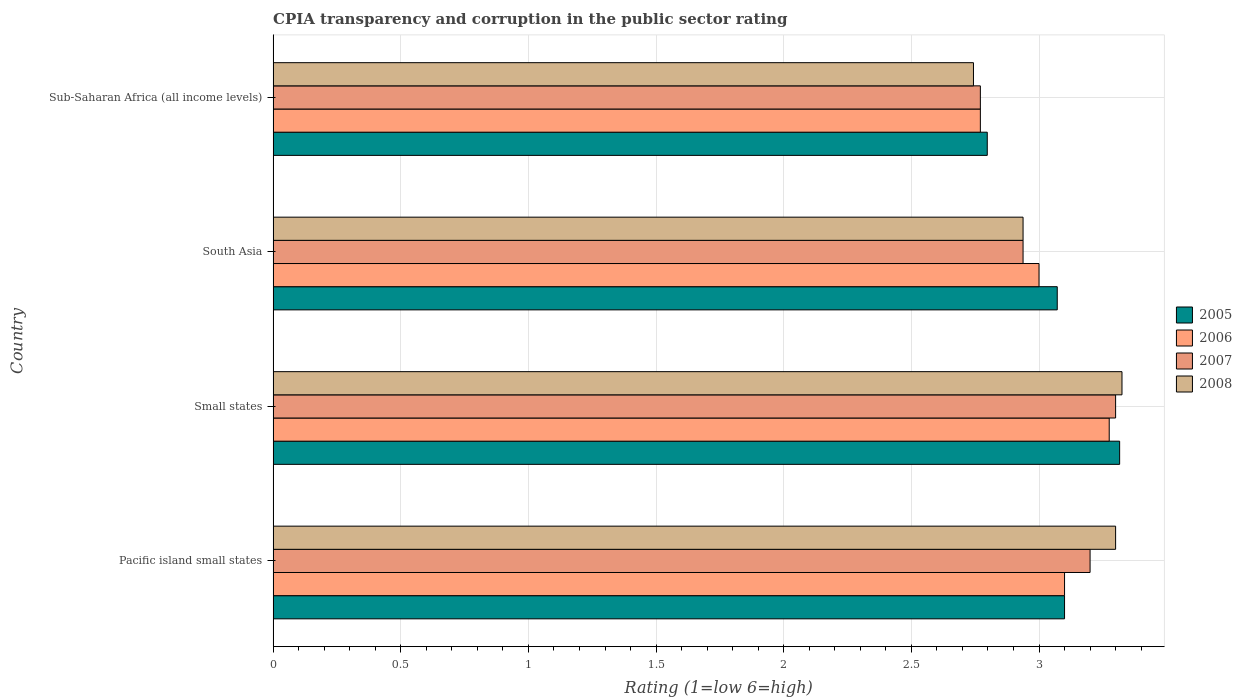How many different coloured bars are there?
Provide a short and direct response. 4. What is the label of the 3rd group of bars from the top?
Your response must be concise. Small states. Across all countries, what is the maximum CPIA rating in 2005?
Ensure brevity in your answer.  3.32. Across all countries, what is the minimum CPIA rating in 2008?
Your answer should be very brief. 2.74. In which country was the CPIA rating in 2005 maximum?
Provide a short and direct response. Small states. In which country was the CPIA rating in 2008 minimum?
Ensure brevity in your answer.  Sub-Saharan Africa (all income levels). What is the total CPIA rating in 2007 in the graph?
Offer a terse response. 12.21. What is the difference between the CPIA rating in 2006 in South Asia and that in Sub-Saharan Africa (all income levels)?
Provide a succinct answer. 0.23. What is the difference between the CPIA rating in 2007 in South Asia and the CPIA rating in 2005 in Small states?
Offer a terse response. -0.38. What is the average CPIA rating in 2005 per country?
Your answer should be compact. 3.07. What is the difference between the CPIA rating in 2006 and CPIA rating in 2005 in Small states?
Give a very brief answer. -0.04. What is the ratio of the CPIA rating in 2006 in South Asia to that in Sub-Saharan Africa (all income levels)?
Offer a terse response. 1.08. Is the CPIA rating in 2008 in Pacific island small states less than that in Sub-Saharan Africa (all income levels)?
Give a very brief answer. No. What is the difference between the highest and the second highest CPIA rating in 2007?
Your response must be concise. 0.1. What is the difference between the highest and the lowest CPIA rating in 2008?
Provide a short and direct response. 0.58. What does the 2nd bar from the top in South Asia represents?
Your response must be concise. 2007. Is it the case that in every country, the sum of the CPIA rating in 2005 and CPIA rating in 2007 is greater than the CPIA rating in 2008?
Provide a short and direct response. Yes. How many bars are there?
Ensure brevity in your answer.  16. How many countries are there in the graph?
Ensure brevity in your answer.  4. What is the difference between two consecutive major ticks on the X-axis?
Make the answer very short. 0.5. Does the graph contain any zero values?
Your answer should be very brief. No. Does the graph contain grids?
Provide a short and direct response. Yes. Where does the legend appear in the graph?
Your response must be concise. Center right. How many legend labels are there?
Keep it short and to the point. 4. How are the legend labels stacked?
Your response must be concise. Vertical. What is the title of the graph?
Offer a terse response. CPIA transparency and corruption in the public sector rating. Does "1976" appear as one of the legend labels in the graph?
Offer a very short reply. No. What is the label or title of the X-axis?
Give a very brief answer. Rating (1=low 6=high). What is the label or title of the Y-axis?
Your answer should be very brief. Country. What is the Rating (1=low 6=high) of 2005 in Small states?
Provide a succinct answer. 3.32. What is the Rating (1=low 6=high) in 2006 in Small states?
Make the answer very short. 3.27. What is the Rating (1=low 6=high) of 2007 in Small states?
Provide a succinct answer. 3.3. What is the Rating (1=low 6=high) in 2008 in Small states?
Ensure brevity in your answer.  3.33. What is the Rating (1=low 6=high) of 2005 in South Asia?
Your answer should be compact. 3.07. What is the Rating (1=low 6=high) in 2007 in South Asia?
Offer a very short reply. 2.94. What is the Rating (1=low 6=high) of 2008 in South Asia?
Provide a succinct answer. 2.94. What is the Rating (1=low 6=high) in 2005 in Sub-Saharan Africa (all income levels)?
Keep it short and to the point. 2.8. What is the Rating (1=low 6=high) in 2006 in Sub-Saharan Africa (all income levels)?
Your answer should be very brief. 2.77. What is the Rating (1=low 6=high) in 2007 in Sub-Saharan Africa (all income levels)?
Provide a short and direct response. 2.77. What is the Rating (1=low 6=high) of 2008 in Sub-Saharan Africa (all income levels)?
Make the answer very short. 2.74. Across all countries, what is the maximum Rating (1=low 6=high) of 2005?
Provide a short and direct response. 3.32. Across all countries, what is the maximum Rating (1=low 6=high) in 2006?
Give a very brief answer. 3.27. Across all countries, what is the maximum Rating (1=low 6=high) in 2007?
Give a very brief answer. 3.3. Across all countries, what is the maximum Rating (1=low 6=high) in 2008?
Provide a succinct answer. 3.33. Across all countries, what is the minimum Rating (1=low 6=high) in 2005?
Give a very brief answer. 2.8. Across all countries, what is the minimum Rating (1=low 6=high) of 2006?
Keep it short and to the point. 2.77. Across all countries, what is the minimum Rating (1=low 6=high) in 2007?
Make the answer very short. 2.77. Across all countries, what is the minimum Rating (1=low 6=high) in 2008?
Give a very brief answer. 2.74. What is the total Rating (1=low 6=high) in 2005 in the graph?
Give a very brief answer. 12.28. What is the total Rating (1=low 6=high) in 2006 in the graph?
Your answer should be compact. 12.15. What is the total Rating (1=low 6=high) of 2007 in the graph?
Your answer should be very brief. 12.21. What is the total Rating (1=low 6=high) of 2008 in the graph?
Offer a terse response. 12.31. What is the difference between the Rating (1=low 6=high) of 2005 in Pacific island small states and that in Small states?
Provide a short and direct response. -0.22. What is the difference between the Rating (1=low 6=high) in 2006 in Pacific island small states and that in Small states?
Provide a succinct answer. -0.17. What is the difference between the Rating (1=low 6=high) in 2008 in Pacific island small states and that in Small states?
Ensure brevity in your answer.  -0.03. What is the difference between the Rating (1=low 6=high) of 2005 in Pacific island small states and that in South Asia?
Your answer should be compact. 0.03. What is the difference between the Rating (1=low 6=high) in 2007 in Pacific island small states and that in South Asia?
Ensure brevity in your answer.  0.26. What is the difference between the Rating (1=low 6=high) in 2008 in Pacific island small states and that in South Asia?
Offer a terse response. 0.36. What is the difference between the Rating (1=low 6=high) of 2005 in Pacific island small states and that in Sub-Saharan Africa (all income levels)?
Provide a short and direct response. 0.3. What is the difference between the Rating (1=low 6=high) of 2006 in Pacific island small states and that in Sub-Saharan Africa (all income levels)?
Provide a short and direct response. 0.33. What is the difference between the Rating (1=low 6=high) in 2007 in Pacific island small states and that in Sub-Saharan Africa (all income levels)?
Offer a terse response. 0.43. What is the difference between the Rating (1=low 6=high) in 2008 in Pacific island small states and that in Sub-Saharan Africa (all income levels)?
Make the answer very short. 0.56. What is the difference between the Rating (1=low 6=high) in 2005 in Small states and that in South Asia?
Provide a succinct answer. 0.24. What is the difference between the Rating (1=low 6=high) of 2006 in Small states and that in South Asia?
Give a very brief answer. 0.28. What is the difference between the Rating (1=low 6=high) of 2007 in Small states and that in South Asia?
Ensure brevity in your answer.  0.36. What is the difference between the Rating (1=low 6=high) of 2008 in Small states and that in South Asia?
Ensure brevity in your answer.  0.39. What is the difference between the Rating (1=low 6=high) in 2005 in Small states and that in Sub-Saharan Africa (all income levels)?
Offer a very short reply. 0.52. What is the difference between the Rating (1=low 6=high) of 2006 in Small states and that in Sub-Saharan Africa (all income levels)?
Your answer should be compact. 0.5. What is the difference between the Rating (1=low 6=high) of 2007 in Small states and that in Sub-Saharan Africa (all income levels)?
Your answer should be very brief. 0.53. What is the difference between the Rating (1=low 6=high) in 2008 in Small states and that in Sub-Saharan Africa (all income levels)?
Your answer should be very brief. 0.58. What is the difference between the Rating (1=low 6=high) of 2005 in South Asia and that in Sub-Saharan Africa (all income levels)?
Keep it short and to the point. 0.27. What is the difference between the Rating (1=low 6=high) of 2006 in South Asia and that in Sub-Saharan Africa (all income levels)?
Keep it short and to the point. 0.23. What is the difference between the Rating (1=low 6=high) in 2007 in South Asia and that in Sub-Saharan Africa (all income levels)?
Provide a succinct answer. 0.17. What is the difference between the Rating (1=low 6=high) in 2008 in South Asia and that in Sub-Saharan Africa (all income levels)?
Provide a short and direct response. 0.19. What is the difference between the Rating (1=low 6=high) in 2005 in Pacific island small states and the Rating (1=low 6=high) in 2006 in Small states?
Your answer should be compact. -0.17. What is the difference between the Rating (1=low 6=high) in 2005 in Pacific island small states and the Rating (1=low 6=high) in 2008 in Small states?
Provide a succinct answer. -0.23. What is the difference between the Rating (1=low 6=high) in 2006 in Pacific island small states and the Rating (1=low 6=high) in 2007 in Small states?
Offer a very short reply. -0.2. What is the difference between the Rating (1=low 6=high) of 2006 in Pacific island small states and the Rating (1=low 6=high) of 2008 in Small states?
Offer a very short reply. -0.23. What is the difference between the Rating (1=low 6=high) of 2007 in Pacific island small states and the Rating (1=low 6=high) of 2008 in Small states?
Keep it short and to the point. -0.12. What is the difference between the Rating (1=low 6=high) in 2005 in Pacific island small states and the Rating (1=low 6=high) in 2006 in South Asia?
Your answer should be compact. 0.1. What is the difference between the Rating (1=low 6=high) in 2005 in Pacific island small states and the Rating (1=low 6=high) in 2007 in South Asia?
Keep it short and to the point. 0.16. What is the difference between the Rating (1=low 6=high) of 2005 in Pacific island small states and the Rating (1=low 6=high) of 2008 in South Asia?
Keep it short and to the point. 0.16. What is the difference between the Rating (1=low 6=high) in 2006 in Pacific island small states and the Rating (1=low 6=high) in 2007 in South Asia?
Provide a succinct answer. 0.16. What is the difference between the Rating (1=low 6=high) of 2006 in Pacific island small states and the Rating (1=low 6=high) of 2008 in South Asia?
Keep it short and to the point. 0.16. What is the difference between the Rating (1=low 6=high) in 2007 in Pacific island small states and the Rating (1=low 6=high) in 2008 in South Asia?
Your response must be concise. 0.26. What is the difference between the Rating (1=low 6=high) of 2005 in Pacific island small states and the Rating (1=low 6=high) of 2006 in Sub-Saharan Africa (all income levels)?
Offer a very short reply. 0.33. What is the difference between the Rating (1=low 6=high) of 2005 in Pacific island small states and the Rating (1=low 6=high) of 2007 in Sub-Saharan Africa (all income levels)?
Provide a succinct answer. 0.33. What is the difference between the Rating (1=low 6=high) of 2005 in Pacific island small states and the Rating (1=low 6=high) of 2008 in Sub-Saharan Africa (all income levels)?
Your response must be concise. 0.36. What is the difference between the Rating (1=low 6=high) of 2006 in Pacific island small states and the Rating (1=low 6=high) of 2007 in Sub-Saharan Africa (all income levels)?
Provide a succinct answer. 0.33. What is the difference between the Rating (1=low 6=high) of 2006 in Pacific island small states and the Rating (1=low 6=high) of 2008 in Sub-Saharan Africa (all income levels)?
Your answer should be very brief. 0.36. What is the difference between the Rating (1=low 6=high) in 2007 in Pacific island small states and the Rating (1=low 6=high) in 2008 in Sub-Saharan Africa (all income levels)?
Your response must be concise. 0.46. What is the difference between the Rating (1=low 6=high) in 2005 in Small states and the Rating (1=low 6=high) in 2006 in South Asia?
Your answer should be very brief. 0.32. What is the difference between the Rating (1=low 6=high) of 2005 in Small states and the Rating (1=low 6=high) of 2007 in South Asia?
Offer a very short reply. 0.38. What is the difference between the Rating (1=low 6=high) in 2005 in Small states and the Rating (1=low 6=high) in 2008 in South Asia?
Make the answer very short. 0.38. What is the difference between the Rating (1=low 6=high) in 2006 in Small states and the Rating (1=low 6=high) in 2007 in South Asia?
Give a very brief answer. 0.34. What is the difference between the Rating (1=low 6=high) of 2006 in Small states and the Rating (1=low 6=high) of 2008 in South Asia?
Offer a terse response. 0.34. What is the difference between the Rating (1=low 6=high) of 2007 in Small states and the Rating (1=low 6=high) of 2008 in South Asia?
Provide a succinct answer. 0.36. What is the difference between the Rating (1=low 6=high) of 2005 in Small states and the Rating (1=low 6=high) of 2006 in Sub-Saharan Africa (all income levels)?
Provide a succinct answer. 0.55. What is the difference between the Rating (1=low 6=high) in 2005 in Small states and the Rating (1=low 6=high) in 2007 in Sub-Saharan Africa (all income levels)?
Offer a terse response. 0.55. What is the difference between the Rating (1=low 6=high) in 2005 in Small states and the Rating (1=low 6=high) in 2008 in Sub-Saharan Africa (all income levels)?
Make the answer very short. 0.57. What is the difference between the Rating (1=low 6=high) in 2006 in Small states and the Rating (1=low 6=high) in 2007 in Sub-Saharan Africa (all income levels)?
Your answer should be compact. 0.5. What is the difference between the Rating (1=low 6=high) of 2006 in Small states and the Rating (1=low 6=high) of 2008 in Sub-Saharan Africa (all income levels)?
Your answer should be compact. 0.53. What is the difference between the Rating (1=low 6=high) in 2007 in Small states and the Rating (1=low 6=high) in 2008 in Sub-Saharan Africa (all income levels)?
Keep it short and to the point. 0.56. What is the difference between the Rating (1=low 6=high) in 2005 in South Asia and the Rating (1=low 6=high) in 2006 in Sub-Saharan Africa (all income levels)?
Offer a terse response. 0.3. What is the difference between the Rating (1=low 6=high) in 2005 in South Asia and the Rating (1=low 6=high) in 2007 in Sub-Saharan Africa (all income levels)?
Offer a very short reply. 0.3. What is the difference between the Rating (1=low 6=high) in 2005 in South Asia and the Rating (1=low 6=high) in 2008 in Sub-Saharan Africa (all income levels)?
Your response must be concise. 0.33. What is the difference between the Rating (1=low 6=high) of 2006 in South Asia and the Rating (1=low 6=high) of 2007 in Sub-Saharan Africa (all income levels)?
Your answer should be very brief. 0.23. What is the difference between the Rating (1=low 6=high) in 2006 in South Asia and the Rating (1=low 6=high) in 2008 in Sub-Saharan Africa (all income levels)?
Your answer should be very brief. 0.26. What is the difference between the Rating (1=low 6=high) of 2007 in South Asia and the Rating (1=low 6=high) of 2008 in Sub-Saharan Africa (all income levels)?
Provide a succinct answer. 0.19. What is the average Rating (1=low 6=high) of 2005 per country?
Your answer should be very brief. 3.07. What is the average Rating (1=low 6=high) of 2006 per country?
Keep it short and to the point. 3.04. What is the average Rating (1=low 6=high) of 2007 per country?
Make the answer very short. 3.05. What is the average Rating (1=low 6=high) in 2008 per country?
Offer a very short reply. 3.08. What is the difference between the Rating (1=low 6=high) of 2005 and Rating (1=low 6=high) of 2008 in Pacific island small states?
Your answer should be compact. -0.2. What is the difference between the Rating (1=low 6=high) in 2006 and Rating (1=low 6=high) in 2007 in Pacific island small states?
Your answer should be very brief. -0.1. What is the difference between the Rating (1=low 6=high) of 2006 and Rating (1=low 6=high) of 2008 in Pacific island small states?
Your answer should be very brief. -0.2. What is the difference between the Rating (1=low 6=high) of 2007 and Rating (1=low 6=high) of 2008 in Pacific island small states?
Offer a terse response. -0.1. What is the difference between the Rating (1=low 6=high) of 2005 and Rating (1=low 6=high) of 2006 in Small states?
Offer a terse response. 0.04. What is the difference between the Rating (1=low 6=high) in 2005 and Rating (1=low 6=high) in 2007 in Small states?
Offer a terse response. 0.02. What is the difference between the Rating (1=low 6=high) of 2005 and Rating (1=low 6=high) of 2008 in Small states?
Ensure brevity in your answer.  -0.01. What is the difference between the Rating (1=low 6=high) in 2006 and Rating (1=low 6=high) in 2007 in Small states?
Your answer should be very brief. -0.03. What is the difference between the Rating (1=low 6=high) of 2006 and Rating (1=low 6=high) of 2008 in Small states?
Offer a terse response. -0.05. What is the difference between the Rating (1=low 6=high) of 2007 and Rating (1=low 6=high) of 2008 in Small states?
Your response must be concise. -0.03. What is the difference between the Rating (1=low 6=high) in 2005 and Rating (1=low 6=high) in 2006 in South Asia?
Offer a very short reply. 0.07. What is the difference between the Rating (1=low 6=high) in 2005 and Rating (1=low 6=high) in 2007 in South Asia?
Make the answer very short. 0.13. What is the difference between the Rating (1=low 6=high) of 2005 and Rating (1=low 6=high) of 2008 in South Asia?
Your answer should be compact. 0.13. What is the difference between the Rating (1=low 6=high) of 2006 and Rating (1=low 6=high) of 2007 in South Asia?
Provide a succinct answer. 0.06. What is the difference between the Rating (1=low 6=high) of 2006 and Rating (1=low 6=high) of 2008 in South Asia?
Make the answer very short. 0.06. What is the difference between the Rating (1=low 6=high) of 2007 and Rating (1=low 6=high) of 2008 in South Asia?
Give a very brief answer. 0. What is the difference between the Rating (1=low 6=high) in 2005 and Rating (1=low 6=high) in 2006 in Sub-Saharan Africa (all income levels)?
Keep it short and to the point. 0.03. What is the difference between the Rating (1=low 6=high) in 2005 and Rating (1=low 6=high) in 2007 in Sub-Saharan Africa (all income levels)?
Give a very brief answer. 0.03. What is the difference between the Rating (1=low 6=high) in 2005 and Rating (1=low 6=high) in 2008 in Sub-Saharan Africa (all income levels)?
Make the answer very short. 0.05. What is the difference between the Rating (1=low 6=high) of 2006 and Rating (1=low 6=high) of 2008 in Sub-Saharan Africa (all income levels)?
Provide a short and direct response. 0.03. What is the difference between the Rating (1=low 6=high) of 2007 and Rating (1=low 6=high) of 2008 in Sub-Saharan Africa (all income levels)?
Offer a terse response. 0.03. What is the ratio of the Rating (1=low 6=high) of 2005 in Pacific island small states to that in Small states?
Provide a short and direct response. 0.93. What is the ratio of the Rating (1=low 6=high) in 2006 in Pacific island small states to that in Small states?
Offer a very short reply. 0.95. What is the ratio of the Rating (1=low 6=high) of 2007 in Pacific island small states to that in Small states?
Provide a succinct answer. 0.97. What is the ratio of the Rating (1=low 6=high) in 2008 in Pacific island small states to that in Small states?
Keep it short and to the point. 0.99. What is the ratio of the Rating (1=low 6=high) of 2005 in Pacific island small states to that in South Asia?
Your answer should be compact. 1.01. What is the ratio of the Rating (1=low 6=high) of 2006 in Pacific island small states to that in South Asia?
Offer a very short reply. 1.03. What is the ratio of the Rating (1=low 6=high) of 2007 in Pacific island small states to that in South Asia?
Give a very brief answer. 1.09. What is the ratio of the Rating (1=low 6=high) of 2008 in Pacific island small states to that in South Asia?
Keep it short and to the point. 1.12. What is the ratio of the Rating (1=low 6=high) in 2005 in Pacific island small states to that in Sub-Saharan Africa (all income levels)?
Keep it short and to the point. 1.11. What is the ratio of the Rating (1=low 6=high) of 2006 in Pacific island small states to that in Sub-Saharan Africa (all income levels)?
Your response must be concise. 1.12. What is the ratio of the Rating (1=low 6=high) in 2007 in Pacific island small states to that in Sub-Saharan Africa (all income levels)?
Your response must be concise. 1.16. What is the ratio of the Rating (1=low 6=high) of 2008 in Pacific island small states to that in Sub-Saharan Africa (all income levels)?
Give a very brief answer. 1.2. What is the ratio of the Rating (1=low 6=high) in 2005 in Small states to that in South Asia?
Make the answer very short. 1.08. What is the ratio of the Rating (1=low 6=high) of 2006 in Small states to that in South Asia?
Ensure brevity in your answer.  1.09. What is the ratio of the Rating (1=low 6=high) of 2007 in Small states to that in South Asia?
Provide a short and direct response. 1.12. What is the ratio of the Rating (1=low 6=high) in 2008 in Small states to that in South Asia?
Make the answer very short. 1.13. What is the ratio of the Rating (1=low 6=high) of 2005 in Small states to that in Sub-Saharan Africa (all income levels)?
Keep it short and to the point. 1.19. What is the ratio of the Rating (1=low 6=high) of 2006 in Small states to that in Sub-Saharan Africa (all income levels)?
Provide a short and direct response. 1.18. What is the ratio of the Rating (1=low 6=high) of 2007 in Small states to that in Sub-Saharan Africa (all income levels)?
Make the answer very short. 1.19. What is the ratio of the Rating (1=low 6=high) in 2008 in Small states to that in Sub-Saharan Africa (all income levels)?
Provide a succinct answer. 1.21. What is the ratio of the Rating (1=low 6=high) in 2005 in South Asia to that in Sub-Saharan Africa (all income levels)?
Make the answer very short. 1.1. What is the ratio of the Rating (1=low 6=high) of 2006 in South Asia to that in Sub-Saharan Africa (all income levels)?
Your response must be concise. 1.08. What is the ratio of the Rating (1=low 6=high) of 2007 in South Asia to that in Sub-Saharan Africa (all income levels)?
Provide a succinct answer. 1.06. What is the ratio of the Rating (1=low 6=high) in 2008 in South Asia to that in Sub-Saharan Africa (all income levels)?
Give a very brief answer. 1.07. What is the difference between the highest and the second highest Rating (1=low 6=high) of 2005?
Make the answer very short. 0.22. What is the difference between the highest and the second highest Rating (1=low 6=high) of 2006?
Offer a very short reply. 0.17. What is the difference between the highest and the second highest Rating (1=low 6=high) of 2008?
Keep it short and to the point. 0.03. What is the difference between the highest and the lowest Rating (1=low 6=high) in 2005?
Keep it short and to the point. 0.52. What is the difference between the highest and the lowest Rating (1=low 6=high) in 2006?
Your response must be concise. 0.5. What is the difference between the highest and the lowest Rating (1=low 6=high) of 2007?
Provide a short and direct response. 0.53. What is the difference between the highest and the lowest Rating (1=low 6=high) in 2008?
Offer a terse response. 0.58. 